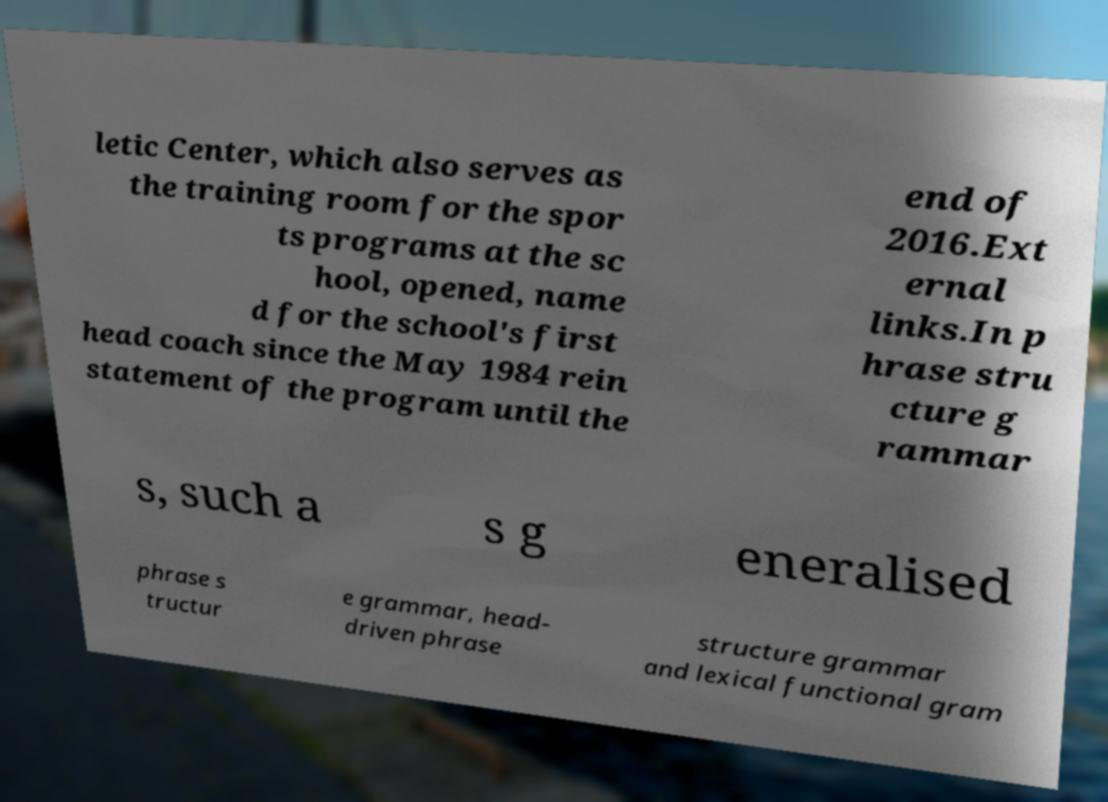Can you read and provide the text displayed in the image?This photo seems to have some interesting text. Can you extract and type it out for me? letic Center, which also serves as the training room for the spor ts programs at the sc hool, opened, name d for the school's first head coach since the May 1984 rein statement of the program until the end of 2016.Ext ernal links.In p hrase stru cture g rammar s, such a s g eneralised phrase s tructur e grammar, head- driven phrase structure grammar and lexical functional gram 